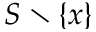<formula> <loc_0><loc_0><loc_500><loc_500>S \ \{ x \}</formula> 